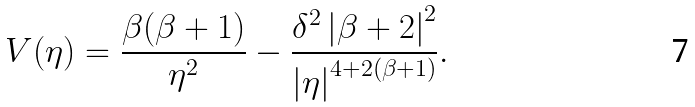<formula> <loc_0><loc_0><loc_500><loc_500>V ( \eta ) = \frac { \beta ( \beta + 1 ) } { \eta ^ { 2 } } - \frac { \delta ^ { 2 } \left | \beta + 2 \right | ^ { 2 } } { \left | \eta \right | ^ { 4 + 2 ( \beta + 1 ) } } .</formula> 